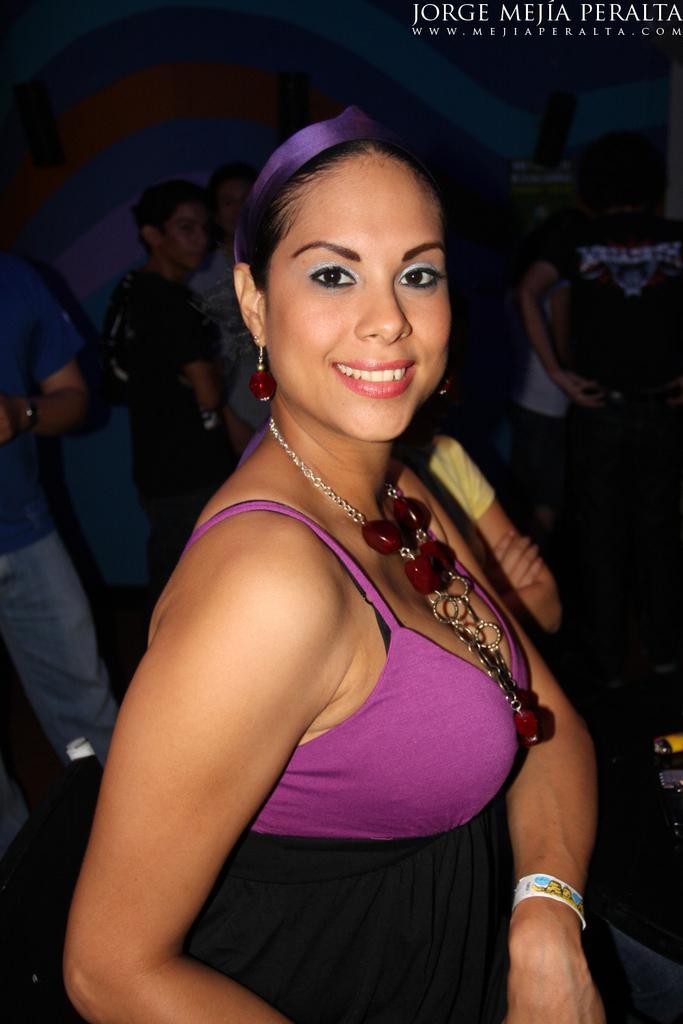Describe this image in one or two sentences. In this picture I can observe a woman wearing violet and black color dress. Woman is smiling. On the top right side, I can observe some text. In the background there are some people standing. 